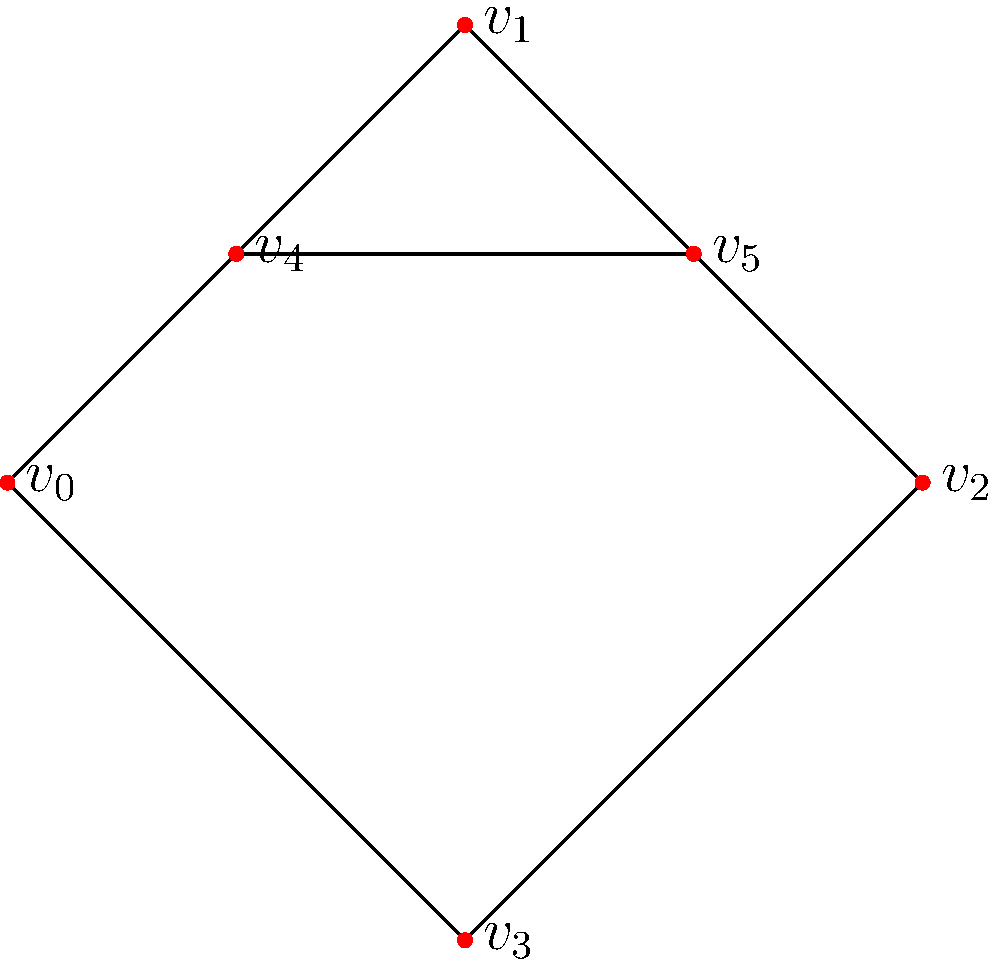Given the skeletal structure represented by the graph above, where vertices represent joints and edges represent bones, construct the adjacency matrix for this structure. Then, determine the number of bones (edges) connected to the joint represented by vertex $v_1$. To solve this problem, we'll follow these steps:

1. Construct the adjacency matrix:
   - The adjacency matrix is a 6x6 matrix (as there are 6 vertices).
   - For each pair of vertices, we put a 1 if they are connected by an edge, and 0 otherwise.

   The adjacency matrix A is:

   $$A = \begin{bmatrix}
   0 & 1 & 0 & 1 & 0 & 0 \\
   1 & 0 & 1 & 0 & 1 & 0 \\
   0 & 1 & 0 & 1 & 0 & 1 \\
   1 & 0 & 1 & 0 & 0 & 0 \\
   0 & 1 & 0 & 0 & 0 & 1 \\
   0 & 0 & 1 & 0 & 1 & 0
   \end{bmatrix}$$

2. To determine the number of bones connected to $v_1$:
   - Look at the row (or column, as the matrix is symmetric) corresponding to $v_1$.
   - Count the number of 1's in this row/column.

   The row for $v_1$ is $[1, 0, 1, 0, 1, 0]$.

3. Count the number of 1's in this row:
   There are 3 ones in this row.

Therefore, vertex $v_1$ is connected to 3 bones.
Answer: 3 